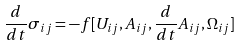<formula> <loc_0><loc_0><loc_500><loc_500>\frac { d } { d t } \sigma _ { i j } = - f [ U _ { i j } , A _ { i j } , \frac { d } { d t } A _ { i j } , \Omega _ { i j } ]</formula> 